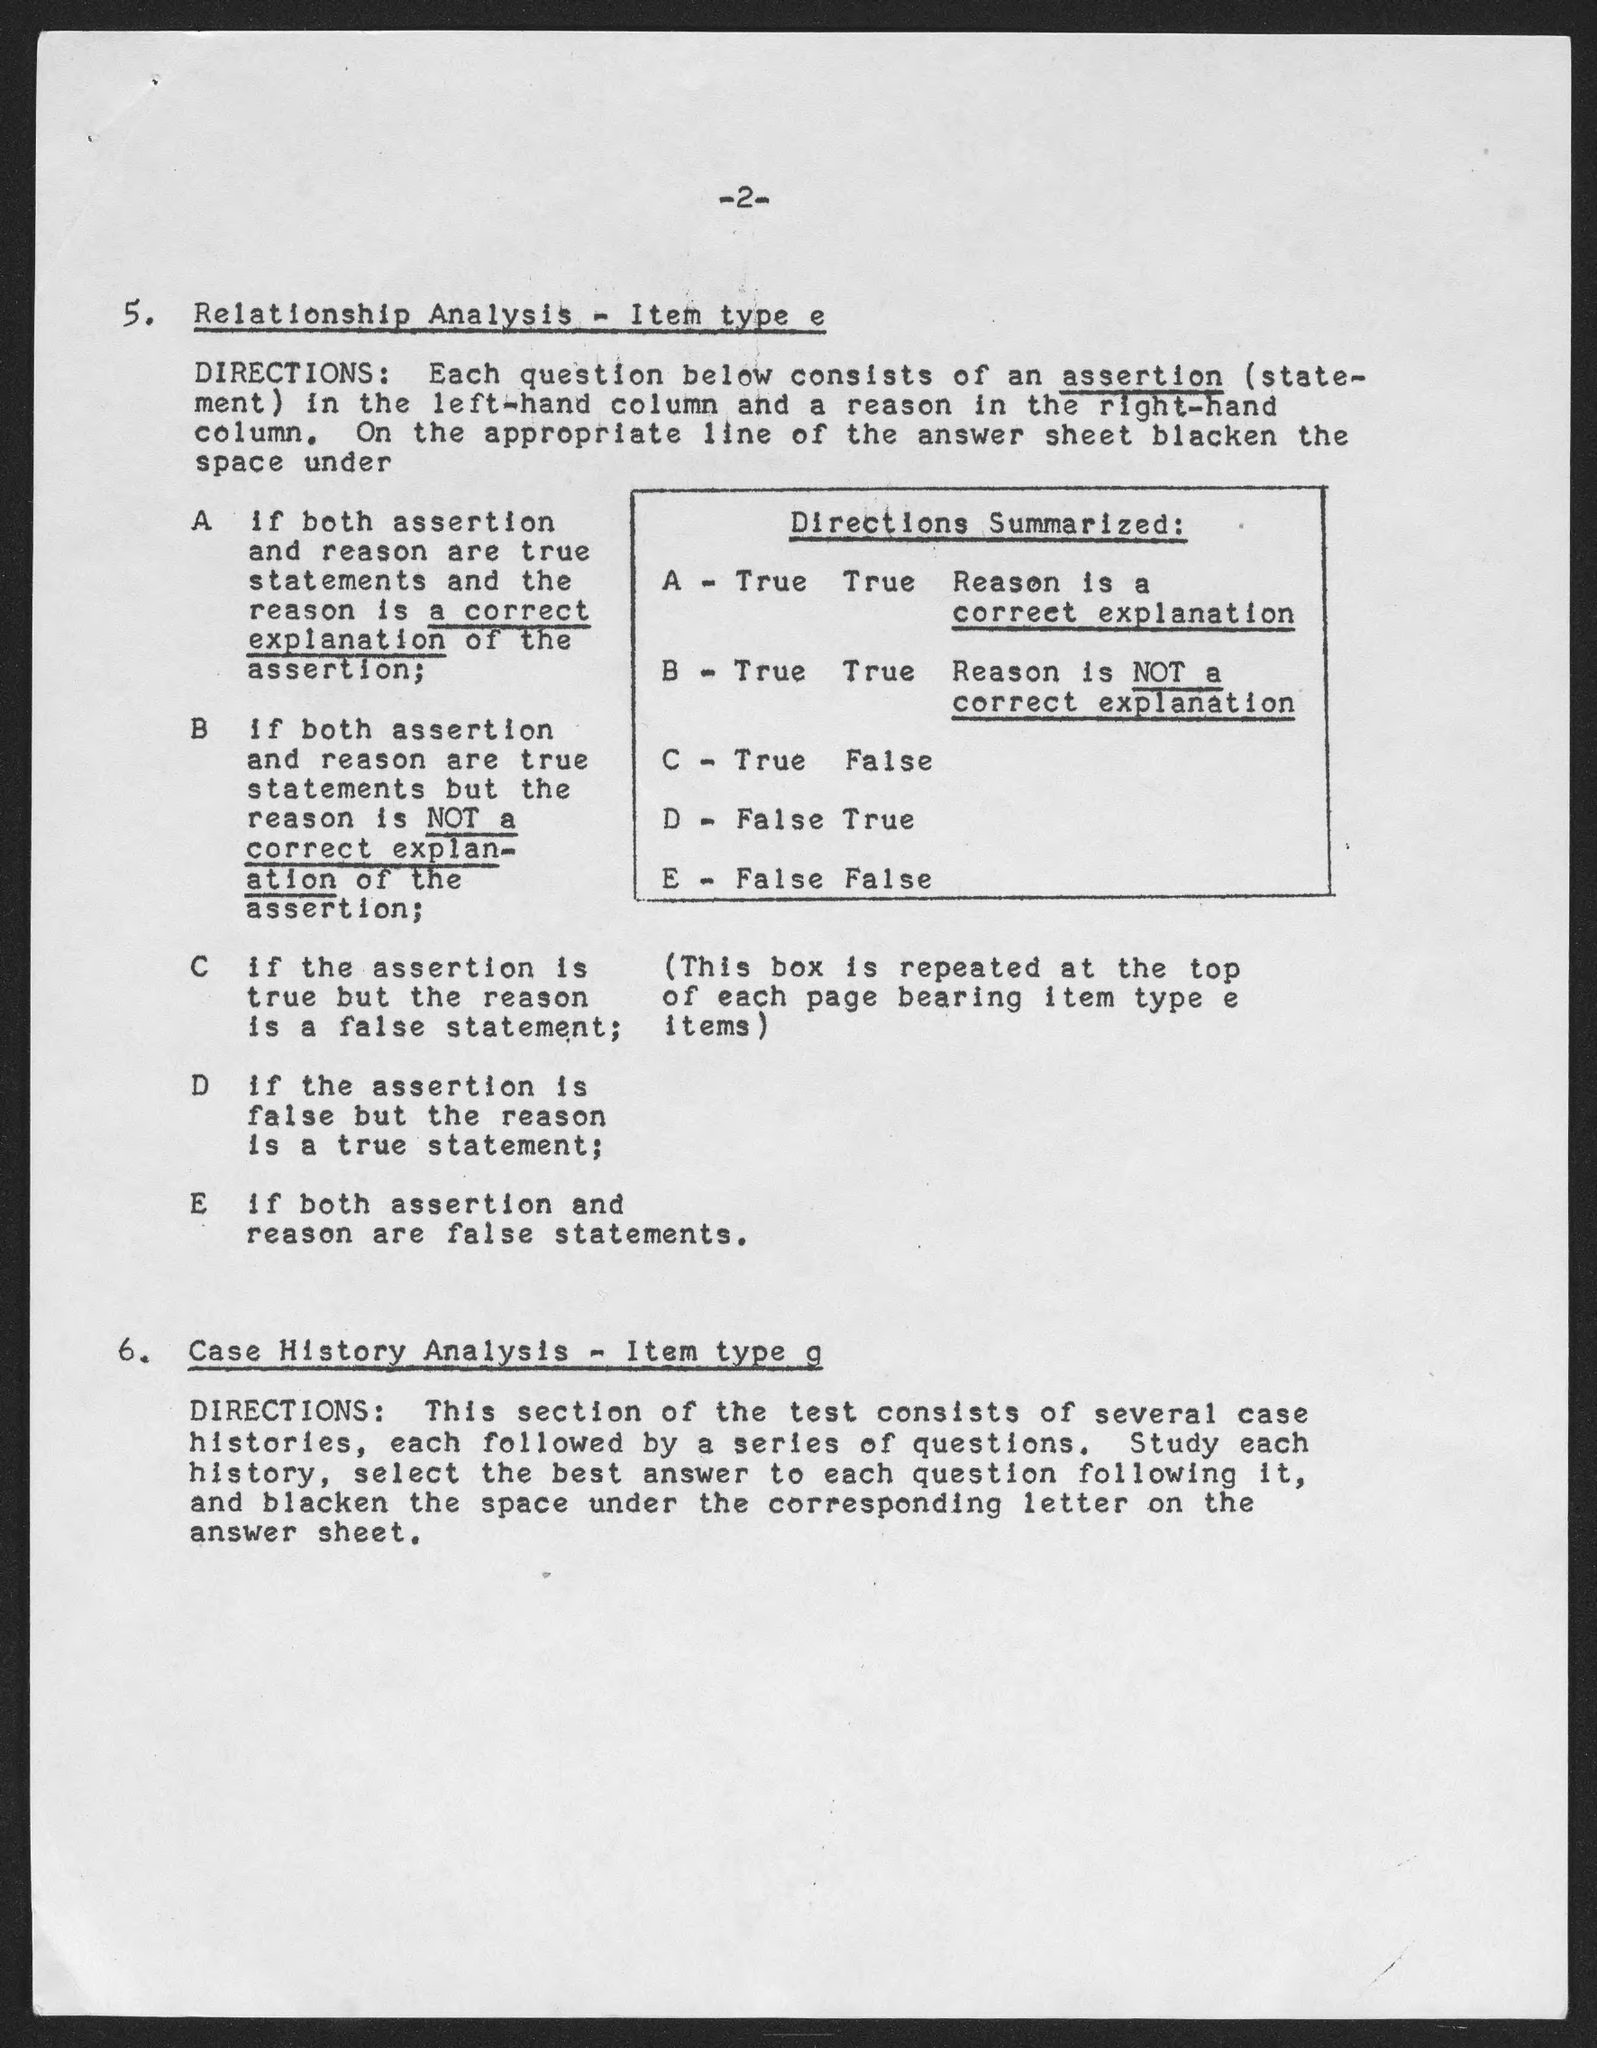Point out several critical features in this image. The document's first title is 'Relationship analysis - item type e..'. I am holding a page numbered 2 and I am currently on that page. 